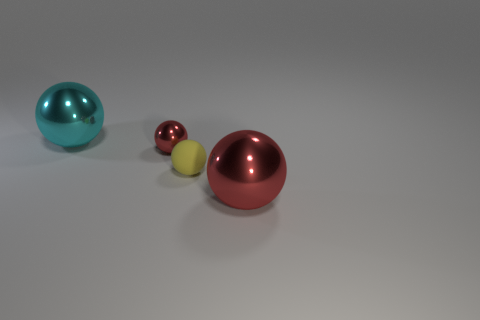Add 4 tiny metal objects. How many objects exist? 8 Add 1 yellow matte objects. How many yellow matte objects are left? 2 Add 1 cyan metallic spheres. How many cyan metallic spheres exist? 2 Subtract 0 blue spheres. How many objects are left? 4 Subtract all red metallic things. Subtract all yellow rubber things. How many objects are left? 1 